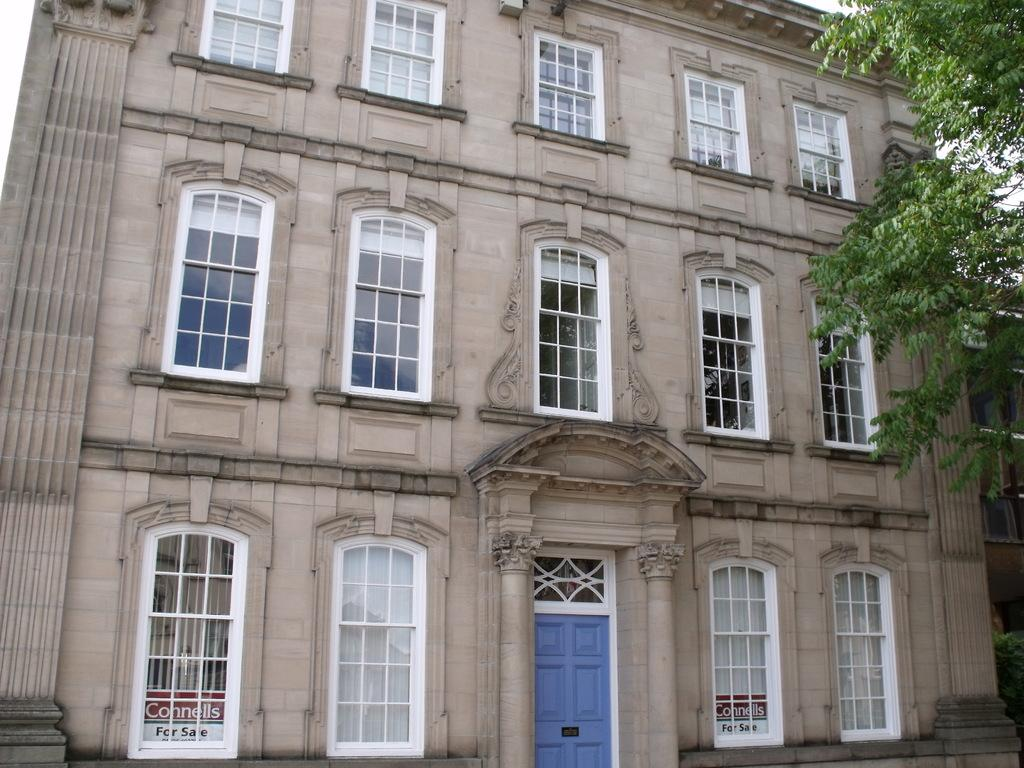What is the main structure in the image? There is a building in the image. What feature can be seen on the building? The building has windows. What type of natural elements can be seen in the image? There are leaves visible in the top right corner of the image. What type of cord is hanging from the building in the image? There is no cord visible in the image; only the building and leaves are present. 